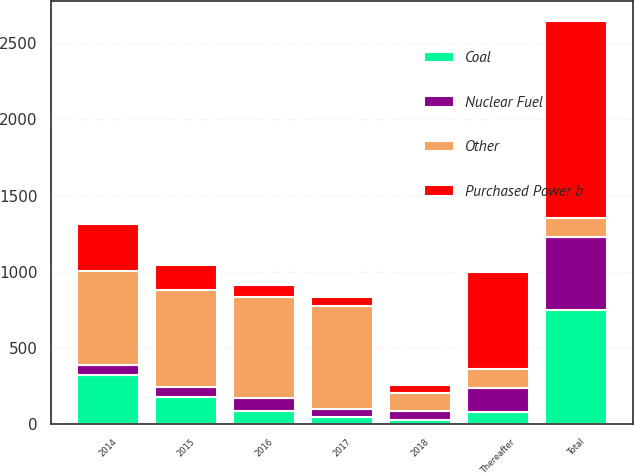<chart> <loc_0><loc_0><loc_500><loc_500><stacked_bar_chart><ecel><fcel>2014<fcel>2015<fcel>2016<fcel>2017<fcel>2018<fcel>Thereafter<fcel>Total<nl><fcel>Other<fcel>620<fcel>642<fcel>664<fcel>676<fcel>120<fcel>125<fcel>125<nl><fcel>Coal<fcel>323<fcel>179<fcel>90<fcel>45<fcel>28<fcel>82<fcel>747<nl><fcel>Nuclear Fuel<fcel>64<fcel>63<fcel>81<fcel>58<fcel>57<fcel>158<fcel>481<nl><fcel>Purchased Power b<fcel>308<fcel>164<fcel>78<fcel>55<fcel>52<fcel>635<fcel>1292<nl></chart> 